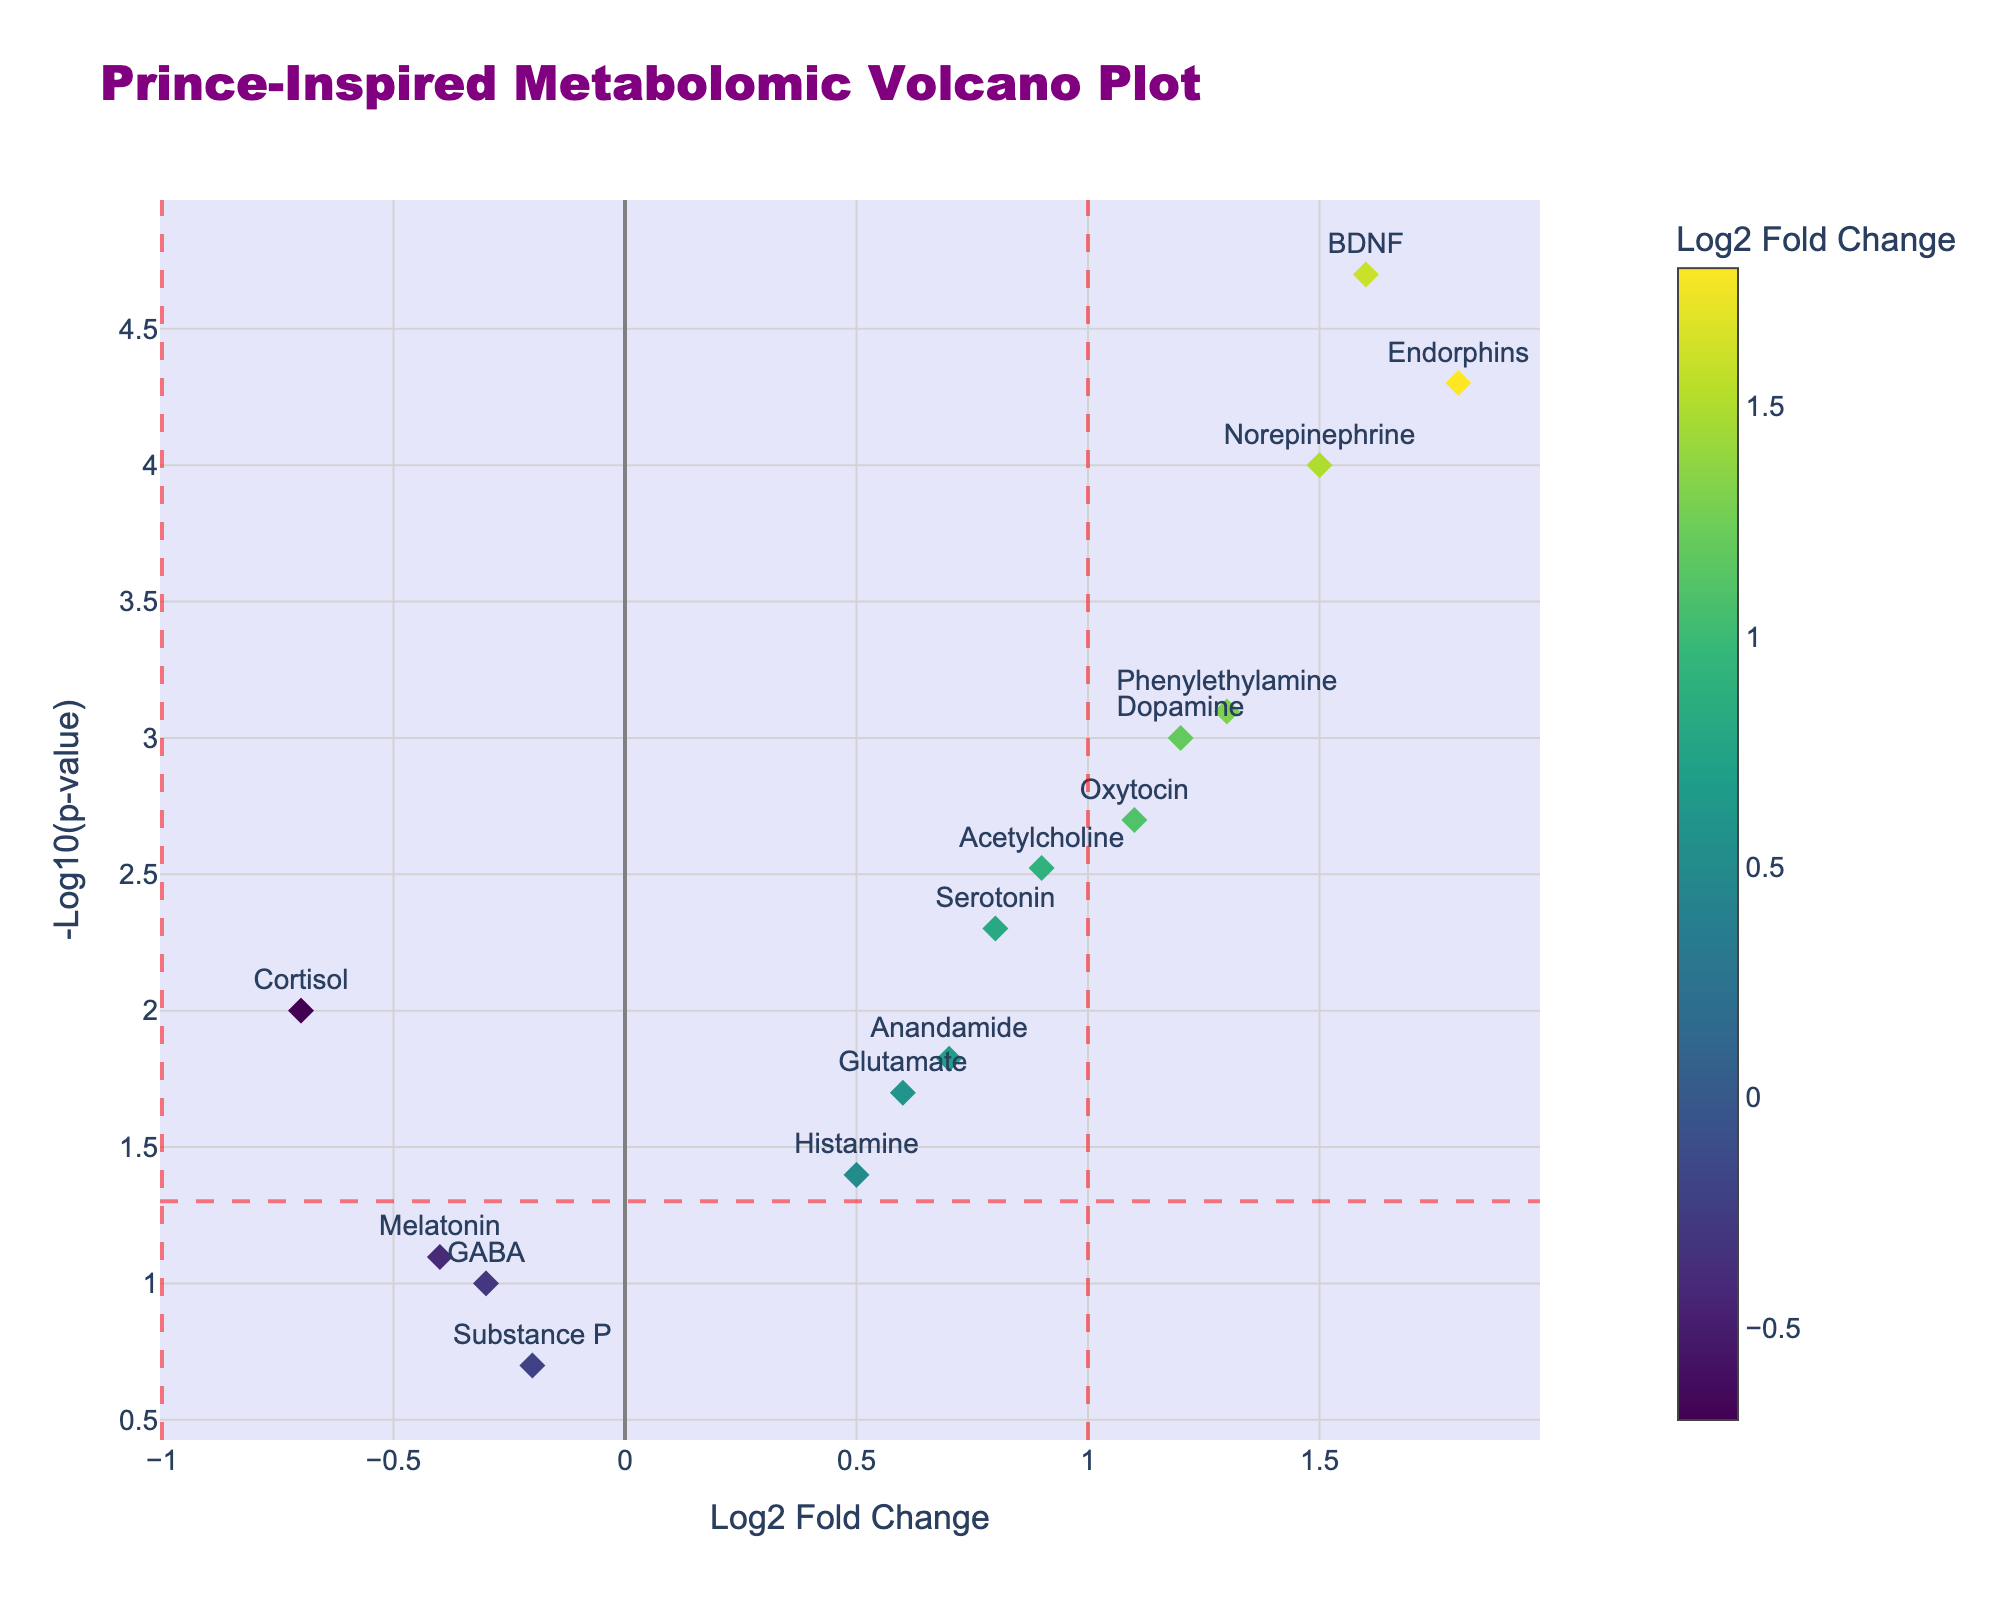How many data points are shown in the volcano plot? By counting the number of data points (markers) in the plot, we can determine there are 15 data points corresponding to 15 metabolites listed in the data.
Answer: 15 What is the title of the Volcano Plot? The title of the plot is displayed at the top of the figure.
Answer: Prince-Inspired Metabolomic Volcano Plot Which metabolite has the highest log2 fold change? By looking at the x-axis (log2 fold change) and identifying the marker with the highest value on this axis, we can see that Norepinephrine has the highest log2 fold change of 1.5.
Answer: Norepinephrine Are there any metabolites with p-values greater than 0.05? We need to see if any markers fall below the horizontal line set at -log10(0.05), which represents p-values greater than 0.05. Substance P (with a p-value of 0.2) and GABA (with a p-value of 0.1) fall below this line, indicating their p-values are greater than 0.05.
Answer: Yes Which metabolite has the highest significance level (lowest p-value)? To find the metabolite with the lowest p-value, locate the data point with the highest -log10(p-value) on the y-axis. The marker with the highest y-coordinate represents the metabolite with the highest significance level, which is Endorphins with a p-value of 0.00005.
Answer: Endorphins How many metabolites show a significant change in levels (p-value < 0.05)? Significant changes are indicated by data points above the horizontal red dashed line at -log10(0.05). Counting these points, we identify 11 metabolites with p-values below 0.05.
Answer: 11 Which metabolite has the lowest log2 fold change after the creative session? By identifying the data point with the lowest value on the x-axis, we can see that Cortisol has the lowest log2 fold change at -0.7.
Answer: Cortisol How many metabolites have a positive log2 fold change and are statistically significant (p-value < 0.05)? Positive log2 fold changes are found on the right side of the vertical line at x=0. Statistically significant points are above the horizontal line at -log10(0.05). Counting these data points, there are 9 metabolites that meet both criteria.
Answer: 9 What does a negative log2 fold change indicate for a metabolite in this analysis? A negative log2 fold change indicates that the level of the metabolite decreased after the Prince-inspired creative session compared to before the session.
Answer: Decrease in levels Which metabolite is more significantly changed, Serotonin or Glutamate? Comparing the -log10(p-value) of Serotonin and Glutamate, Serotonin has a -log10(p-value) of 2.30 while Glutamate has 1.70. Since higher -log10(p-value) indicates greater significance, Serotonin is more significantly changed than Glutamate.
Answer: Serotonin 